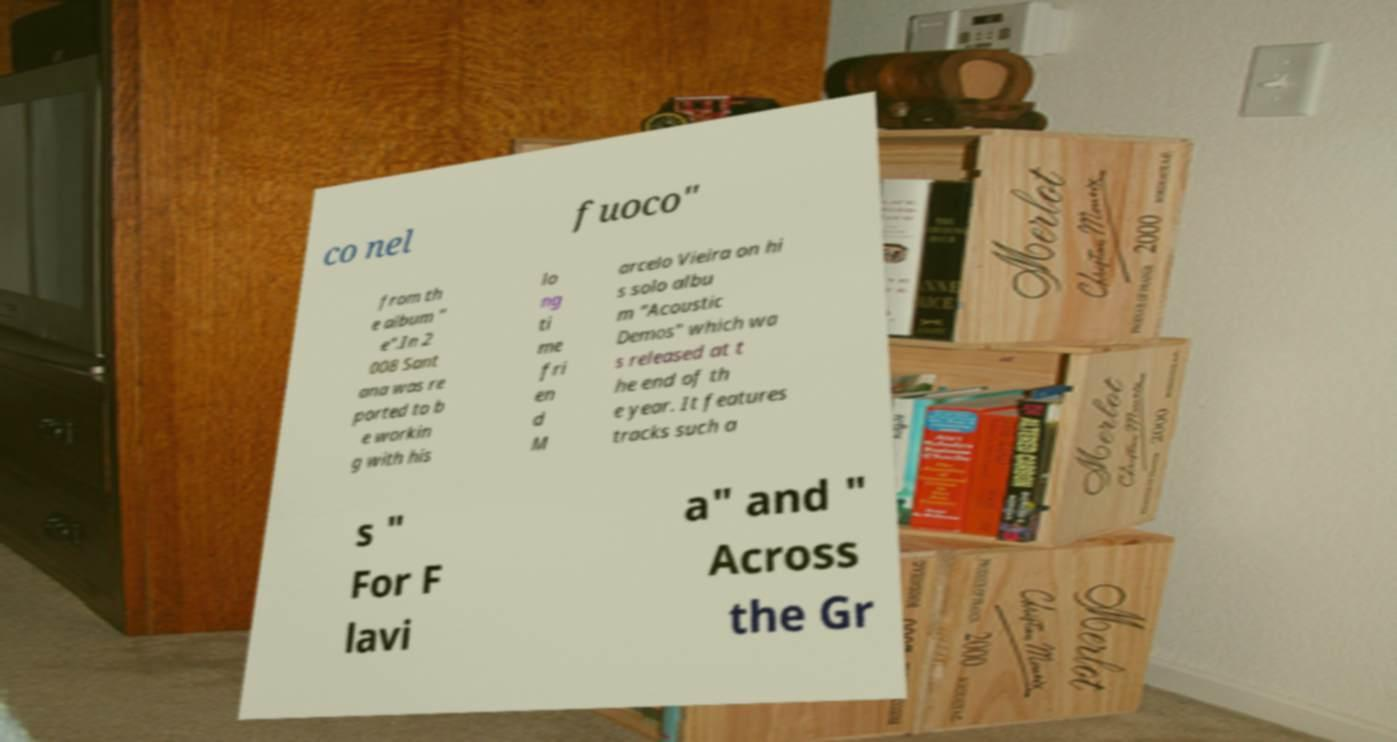For documentation purposes, I need the text within this image transcribed. Could you provide that? co nel fuoco" from th e album " e".In 2 008 Sant ana was re ported to b e workin g with his lo ng ti me fri en d M arcelo Vieira on hi s solo albu m "Acoustic Demos" which wa s released at t he end of th e year. It features tracks such a s " For F lavi a" and " Across the Gr 